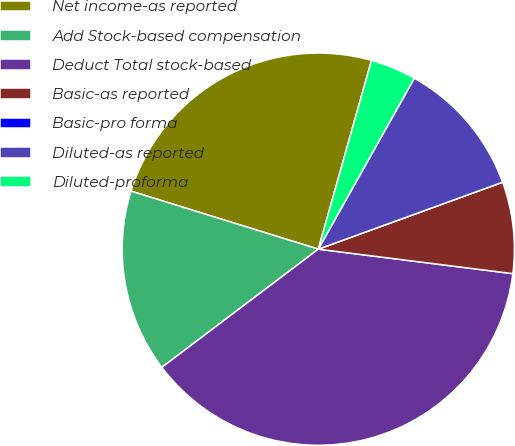Convert chart. <chart><loc_0><loc_0><loc_500><loc_500><pie_chart><fcel>Net income-as reported<fcel>Add Stock-based compensation<fcel>Deduct Total stock-based<fcel>Basic-as reported<fcel>Basic-pro forma<fcel>Diluted-as reported<fcel>Diluted-proforma<nl><fcel>24.59%<fcel>15.08%<fcel>37.71%<fcel>7.54%<fcel>0.0%<fcel>11.31%<fcel>3.77%<nl></chart> 